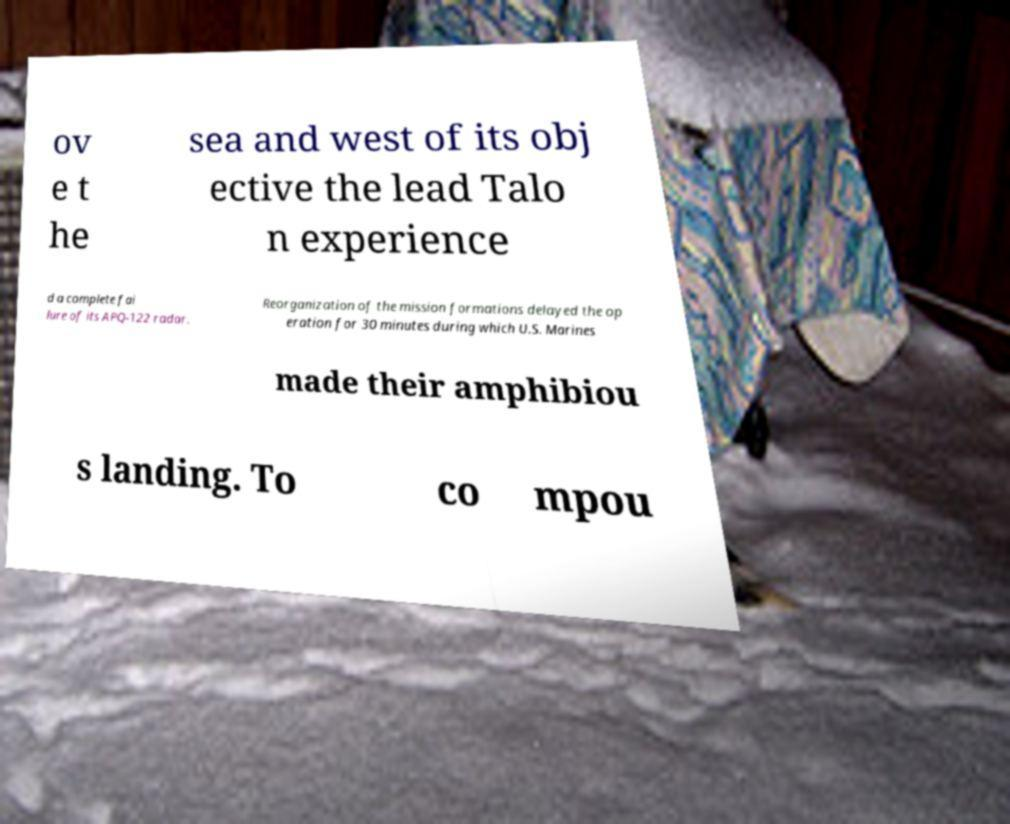For documentation purposes, I need the text within this image transcribed. Could you provide that? ov e t he sea and west of its obj ective the lead Talo n experience d a complete fai lure of its APQ-122 radar. Reorganization of the mission formations delayed the op eration for 30 minutes during which U.S. Marines made their amphibiou s landing. To co mpou 